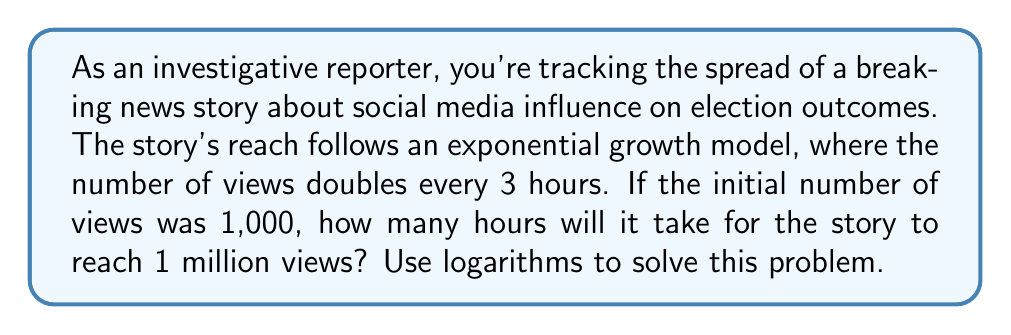Solve this math problem. Let's approach this step-by-step:

1) Let $N(t)$ be the number of views after $t$ hours. We're given that:
   $N(0) = 1,000$ (initial views)
   $N(t) = 1,000,000$ (target views)

2) The exponential growth model is:
   $N(t) = N(0) \cdot 2^{\frac{t}{3}}$

3) Substituting our values:
   $1,000,000 = 1,000 \cdot 2^{\frac{t}{3}}$

4) Divide both sides by 1,000:
   $1,000 = 2^{\frac{t}{3}}$

5) Take the logarithm (base 2) of both sides:
   $\log_2(1,000) = \frac{t}{3}$

6) Multiply both sides by 3:
   $3\log_2(1,000) = t$

7) Calculate $\log_2(1,000)$:
   $\log_2(1,000) = \frac{\log(1,000)}{\log(2)} \approx 9.97$

8) Therefore:
   $t = 3 \cdot 9.97 \approx 29.91$ hours
Answer: It will take approximately 29.91 hours for the news story to reach 1 million views. 